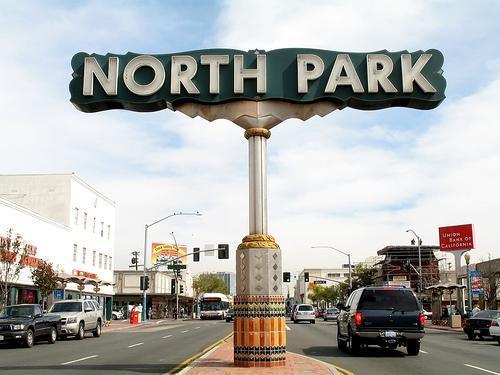How many clock's are in the picture?
Give a very brief answer. 0. 